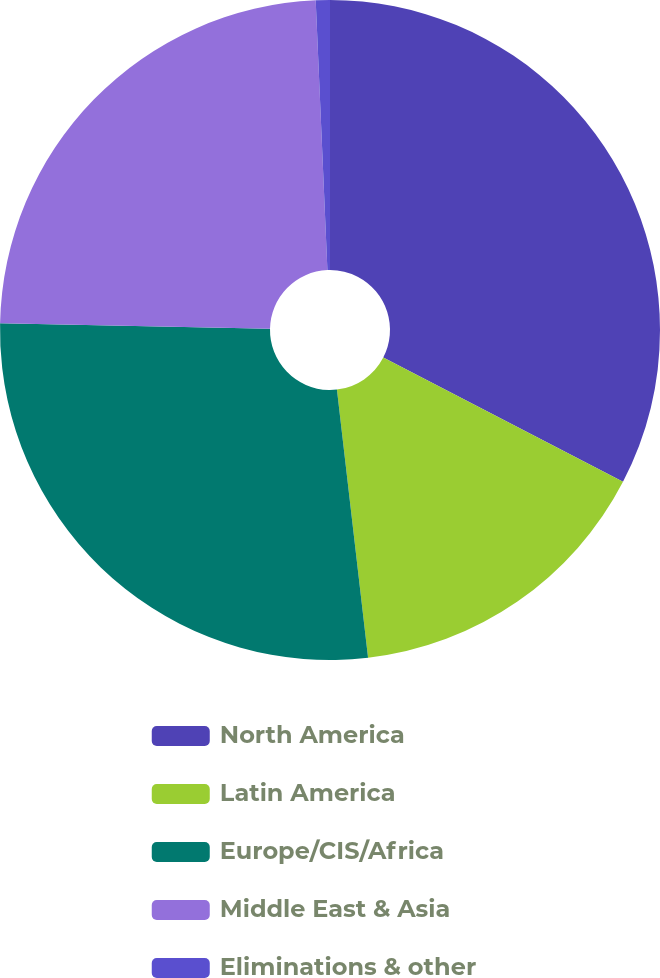Convert chart to OTSL. <chart><loc_0><loc_0><loc_500><loc_500><pie_chart><fcel>North America<fcel>Latin America<fcel>Europe/CIS/Africa<fcel>Middle East & Asia<fcel>Eliminations & other<nl><fcel>32.61%<fcel>15.55%<fcel>27.17%<fcel>23.98%<fcel>0.69%<nl></chart> 